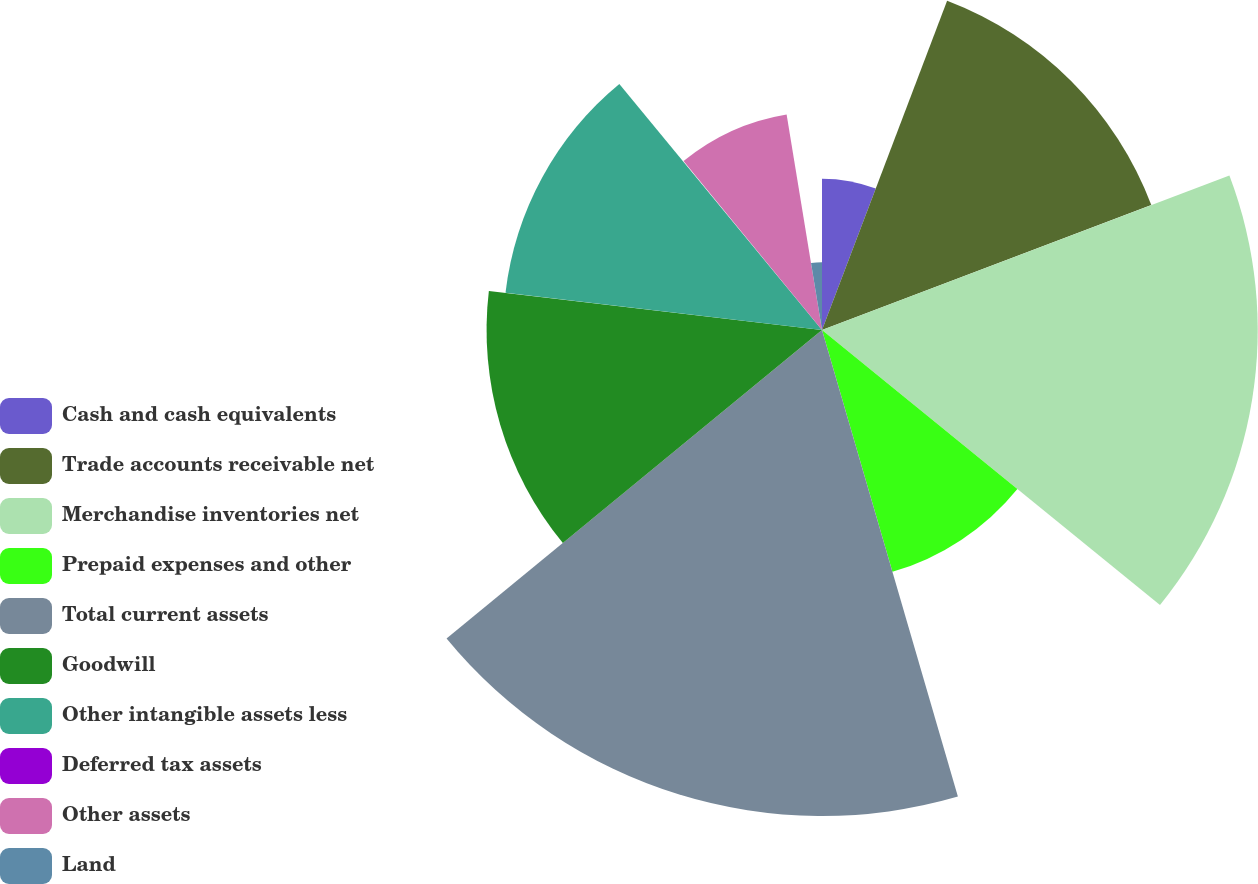Convert chart. <chart><loc_0><loc_0><loc_500><loc_500><pie_chart><fcel>Cash and cash equivalents<fcel>Trade accounts receivable net<fcel>Merchandise inventories net<fcel>Prepaid expenses and other<fcel>Total current assets<fcel>Goodwill<fcel>Other intangible assets less<fcel>Deferred tax assets<fcel>Other assets<fcel>Land<nl><fcel>5.78%<fcel>13.45%<fcel>16.64%<fcel>9.62%<fcel>18.56%<fcel>12.81%<fcel>12.17%<fcel>0.04%<fcel>8.34%<fcel>2.59%<nl></chart> 